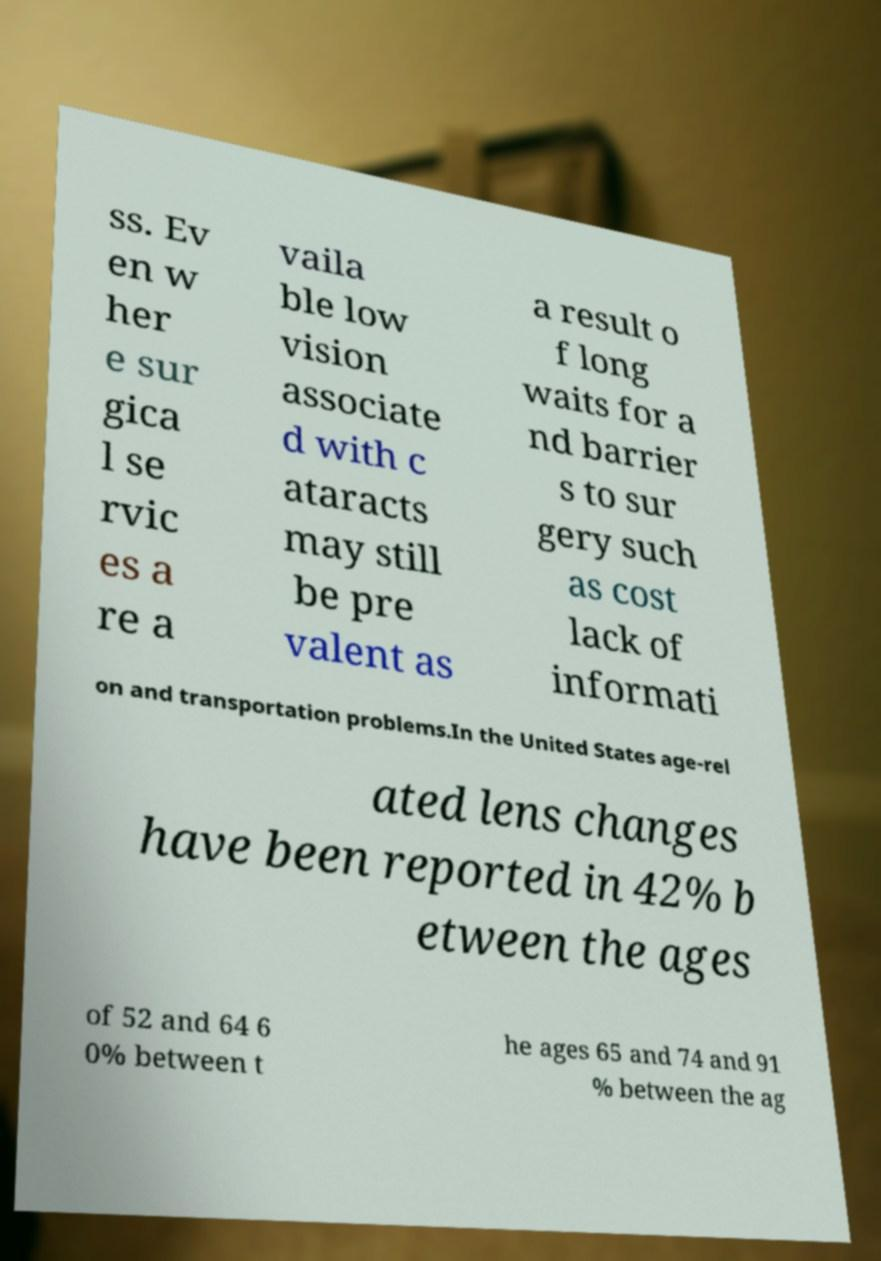I need the written content from this picture converted into text. Can you do that? ss. Ev en w her e sur gica l se rvic es a re a vaila ble low vision associate d with c ataracts may still be pre valent as a result o f long waits for a nd barrier s to sur gery such as cost lack of informati on and transportation problems.In the United States age-rel ated lens changes have been reported in 42% b etween the ages of 52 and 64 6 0% between t he ages 65 and 74 and 91 % between the ag 